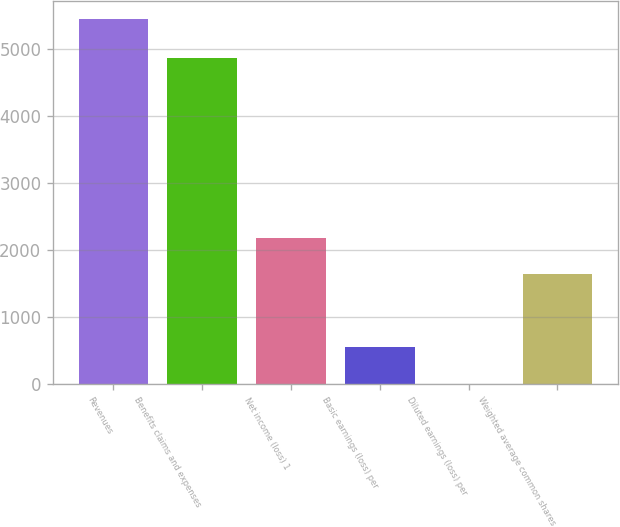Convert chart. <chart><loc_0><loc_0><loc_500><loc_500><bar_chart><fcel>Revenues<fcel>Benefits claims and expenses<fcel>Net income (loss) 1<fcel>Basic earnings (loss) per<fcel>Diluted earnings (loss) per<fcel>Weighted average common shares<nl><fcel>5444<fcel>4867<fcel>2178.46<fcel>545.71<fcel>1.46<fcel>1634.21<nl></chart> 